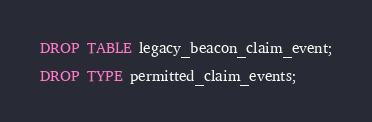<code> <loc_0><loc_0><loc_500><loc_500><_SQL_>DROP TABLE legacy_beacon_claim_event;

DROP TYPE permitted_claim_events;</code> 